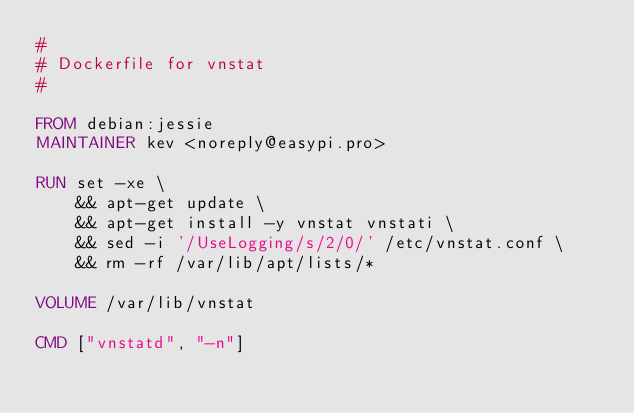Convert code to text. <code><loc_0><loc_0><loc_500><loc_500><_Dockerfile_>#
# Dockerfile for vnstat
#

FROM debian:jessie
MAINTAINER kev <noreply@easypi.pro>

RUN set -xe \
    && apt-get update \
    && apt-get install -y vnstat vnstati \
    && sed -i '/UseLogging/s/2/0/' /etc/vnstat.conf \
    && rm -rf /var/lib/apt/lists/*

VOLUME /var/lib/vnstat

CMD ["vnstatd", "-n"]
</code> 